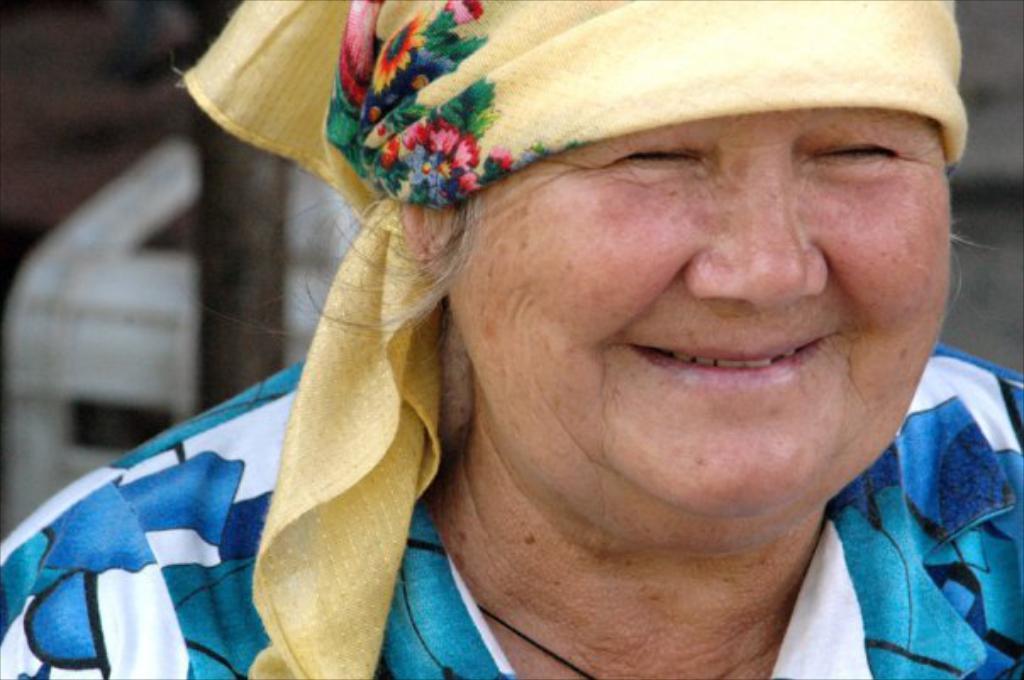In one or two sentences, can you explain what this image depicts? In this image there is a old lady smiling with yellow scarf on head and wearing blue and white shirt. 